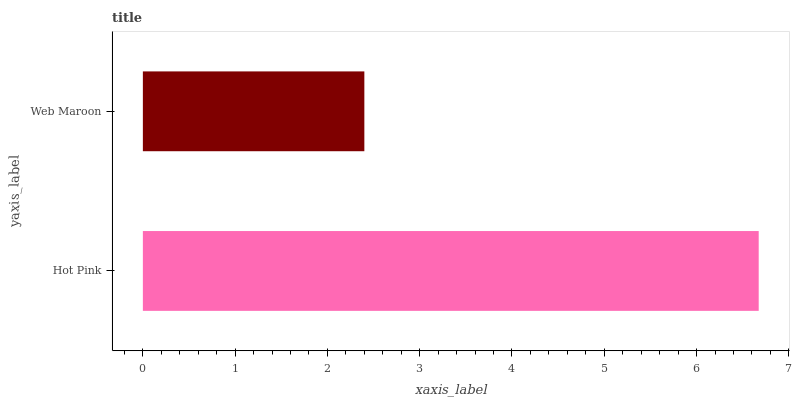Is Web Maroon the minimum?
Answer yes or no. Yes. Is Hot Pink the maximum?
Answer yes or no. Yes. Is Web Maroon the maximum?
Answer yes or no. No. Is Hot Pink greater than Web Maroon?
Answer yes or no. Yes. Is Web Maroon less than Hot Pink?
Answer yes or no. Yes. Is Web Maroon greater than Hot Pink?
Answer yes or no. No. Is Hot Pink less than Web Maroon?
Answer yes or no. No. Is Hot Pink the high median?
Answer yes or no. Yes. Is Web Maroon the low median?
Answer yes or no. Yes. Is Web Maroon the high median?
Answer yes or no. No. Is Hot Pink the low median?
Answer yes or no. No. 